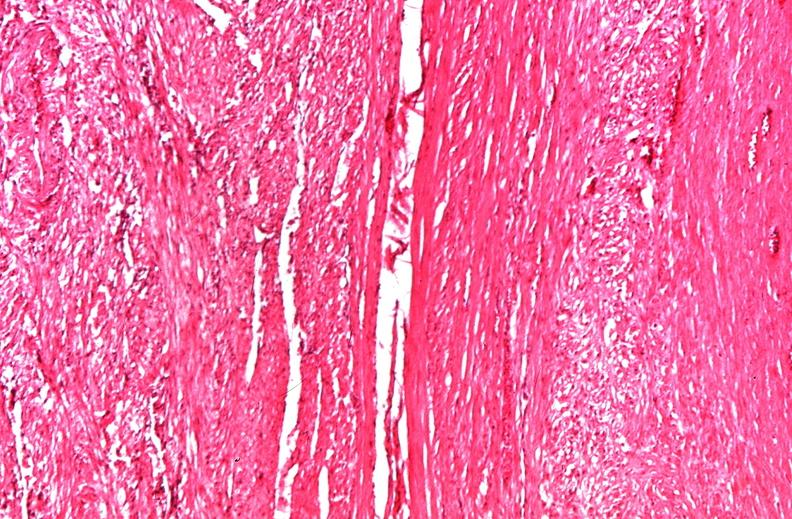s adrenal present?
Answer the question using a single word or phrase. No 